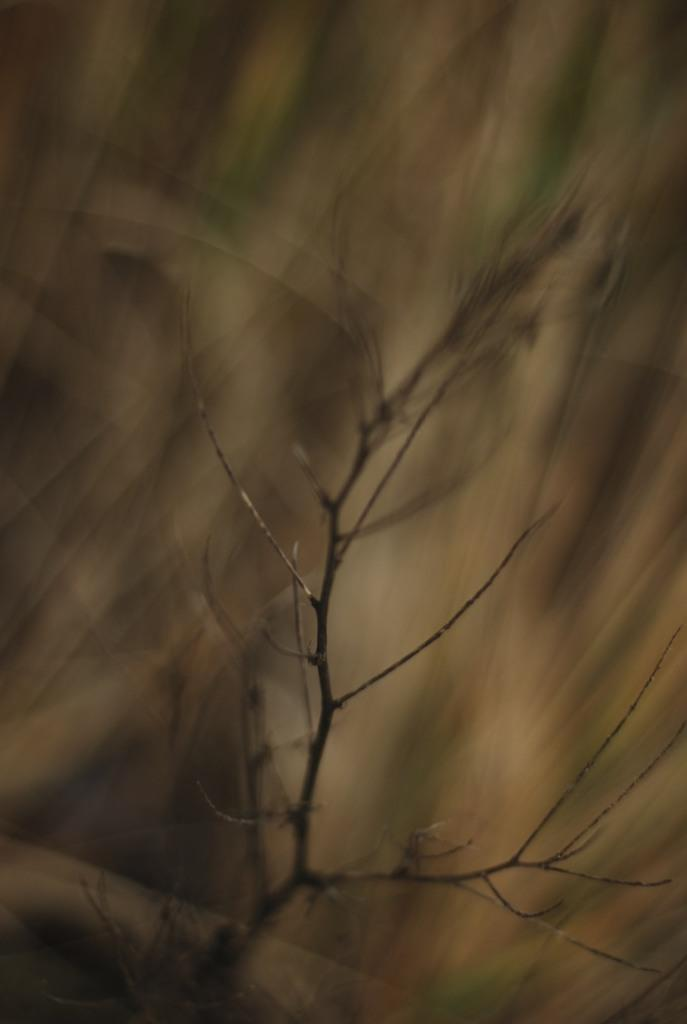What is the main subject of the image? The main subject of the image is a dry branch of a tree. Can you describe the branch in more detail? The branch appears to be dry and may have fallen from a tree. How many letters are attached to the dry branch in the image? There are no letters attached to the dry branch in the image. What type of jelly can be seen dripping from the dry branch in the image? There is no jelly present in the image; it features a dry branch of a tree. What kind of fuel is being used by the dry branch in the image? The dry branch is not using any fuel; it is a stationary object in the image. 